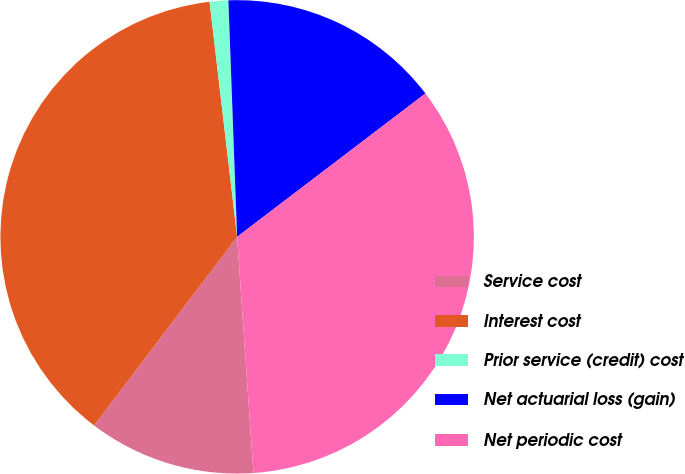Convert chart. <chart><loc_0><loc_0><loc_500><loc_500><pie_chart><fcel>Service cost<fcel>Interest cost<fcel>Prior service (credit) cost<fcel>Net actuarial loss (gain)<fcel>Net periodic cost<nl><fcel>11.42%<fcel>37.82%<fcel>1.27%<fcel>15.23%<fcel>34.26%<nl></chart> 